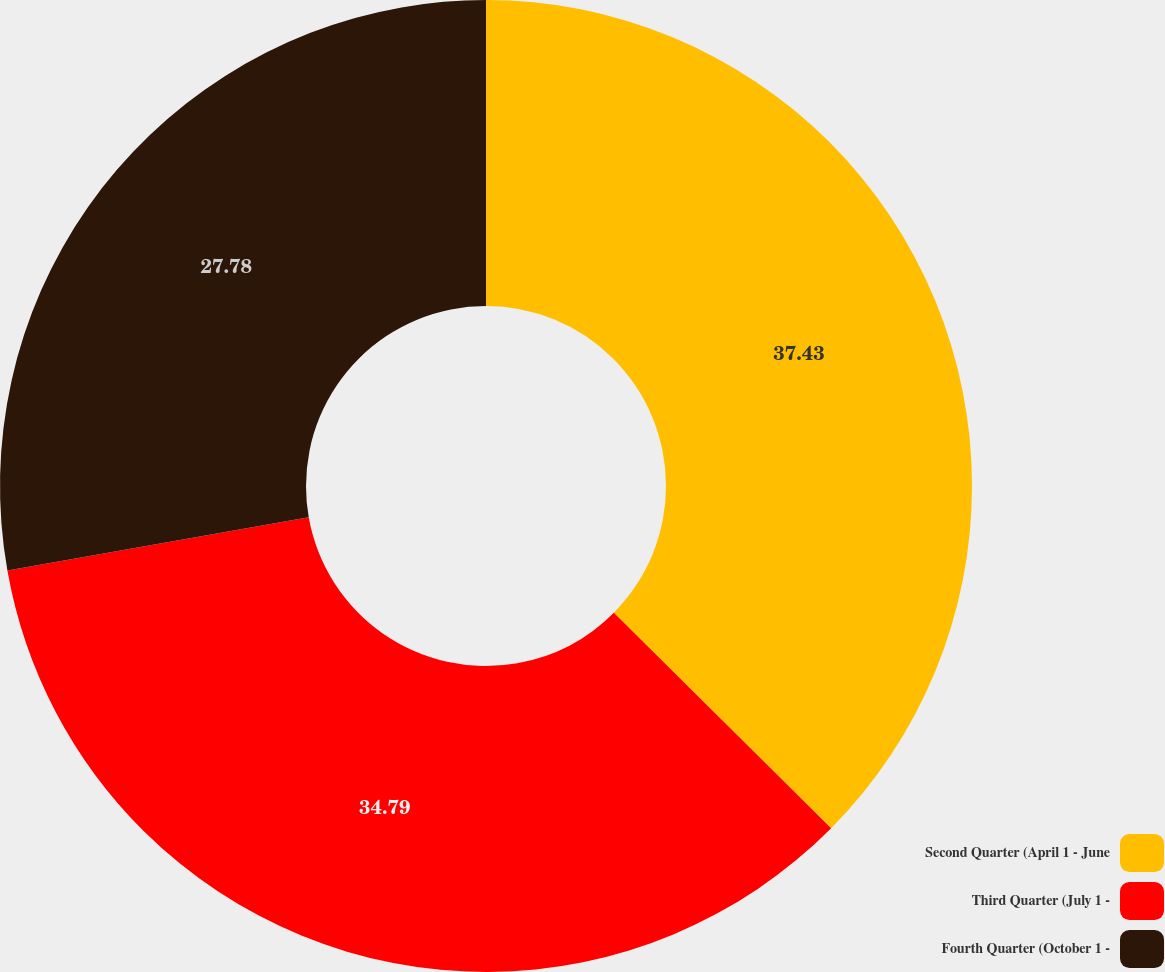Convert chart. <chart><loc_0><loc_0><loc_500><loc_500><pie_chart><fcel>Second Quarter (April 1 - June<fcel>Third Quarter (July 1 -<fcel>Fourth Quarter (October 1 -<nl><fcel>37.43%<fcel>34.79%<fcel>27.78%<nl></chart> 